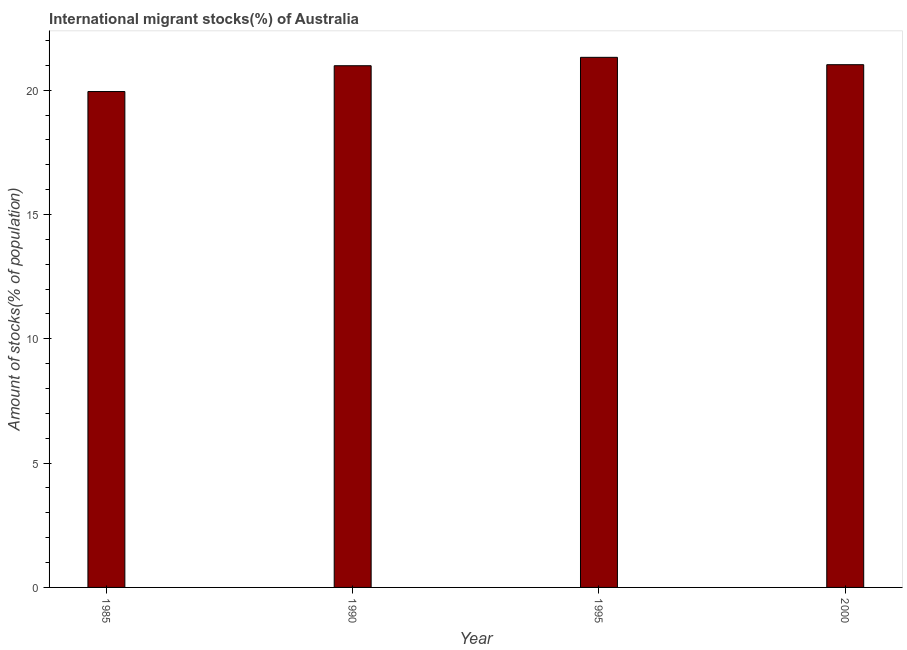Does the graph contain any zero values?
Your answer should be very brief. No. What is the title of the graph?
Make the answer very short. International migrant stocks(%) of Australia. What is the label or title of the X-axis?
Your answer should be very brief. Year. What is the label or title of the Y-axis?
Your answer should be compact. Amount of stocks(% of population). What is the number of international migrant stocks in 1995?
Ensure brevity in your answer.  21.32. Across all years, what is the maximum number of international migrant stocks?
Your response must be concise. 21.32. Across all years, what is the minimum number of international migrant stocks?
Ensure brevity in your answer.  19.95. In which year was the number of international migrant stocks minimum?
Give a very brief answer. 1985. What is the sum of the number of international migrant stocks?
Ensure brevity in your answer.  83.29. What is the difference between the number of international migrant stocks in 1990 and 1995?
Your answer should be very brief. -0.34. What is the average number of international migrant stocks per year?
Give a very brief answer. 20.82. What is the median number of international migrant stocks?
Offer a terse response. 21.01. What is the difference between the highest and the second highest number of international migrant stocks?
Provide a short and direct response. 0.3. What is the difference between the highest and the lowest number of international migrant stocks?
Give a very brief answer. 1.38. How many bars are there?
Keep it short and to the point. 4. What is the difference between two consecutive major ticks on the Y-axis?
Offer a very short reply. 5. Are the values on the major ticks of Y-axis written in scientific E-notation?
Your answer should be very brief. No. What is the Amount of stocks(% of population) in 1985?
Give a very brief answer. 19.95. What is the Amount of stocks(% of population) in 1990?
Your response must be concise. 20.99. What is the Amount of stocks(% of population) of 1995?
Provide a short and direct response. 21.32. What is the Amount of stocks(% of population) of 2000?
Offer a terse response. 21.03. What is the difference between the Amount of stocks(% of population) in 1985 and 1990?
Make the answer very short. -1.04. What is the difference between the Amount of stocks(% of population) in 1985 and 1995?
Ensure brevity in your answer.  -1.38. What is the difference between the Amount of stocks(% of population) in 1985 and 2000?
Offer a terse response. -1.08. What is the difference between the Amount of stocks(% of population) in 1990 and 1995?
Give a very brief answer. -0.34. What is the difference between the Amount of stocks(% of population) in 1990 and 2000?
Ensure brevity in your answer.  -0.04. What is the difference between the Amount of stocks(% of population) in 1995 and 2000?
Give a very brief answer. 0.3. What is the ratio of the Amount of stocks(% of population) in 1985 to that in 1990?
Your response must be concise. 0.95. What is the ratio of the Amount of stocks(% of population) in 1985 to that in 1995?
Make the answer very short. 0.94. What is the ratio of the Amount of stocks(% of population) in 1985 to that in 2000?
Your answer should be compact. 0.95. What is the ratio of the Amount of stocks(% of population) in 1990 to that in 1995?
Give a very brief answer. 0.98. 